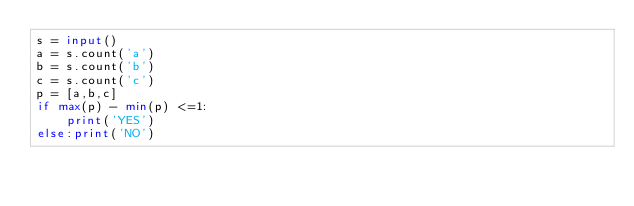<code> <loc_0><loc_0><loc_500><loc_500><_Python_>s = input()
a = s.count('a')
b = s.count('b')
c = s.count('c')
p = [a,b,c]
if max(p) - min(p) <=1:
    print('YES')
else:print('NO')    </code> 